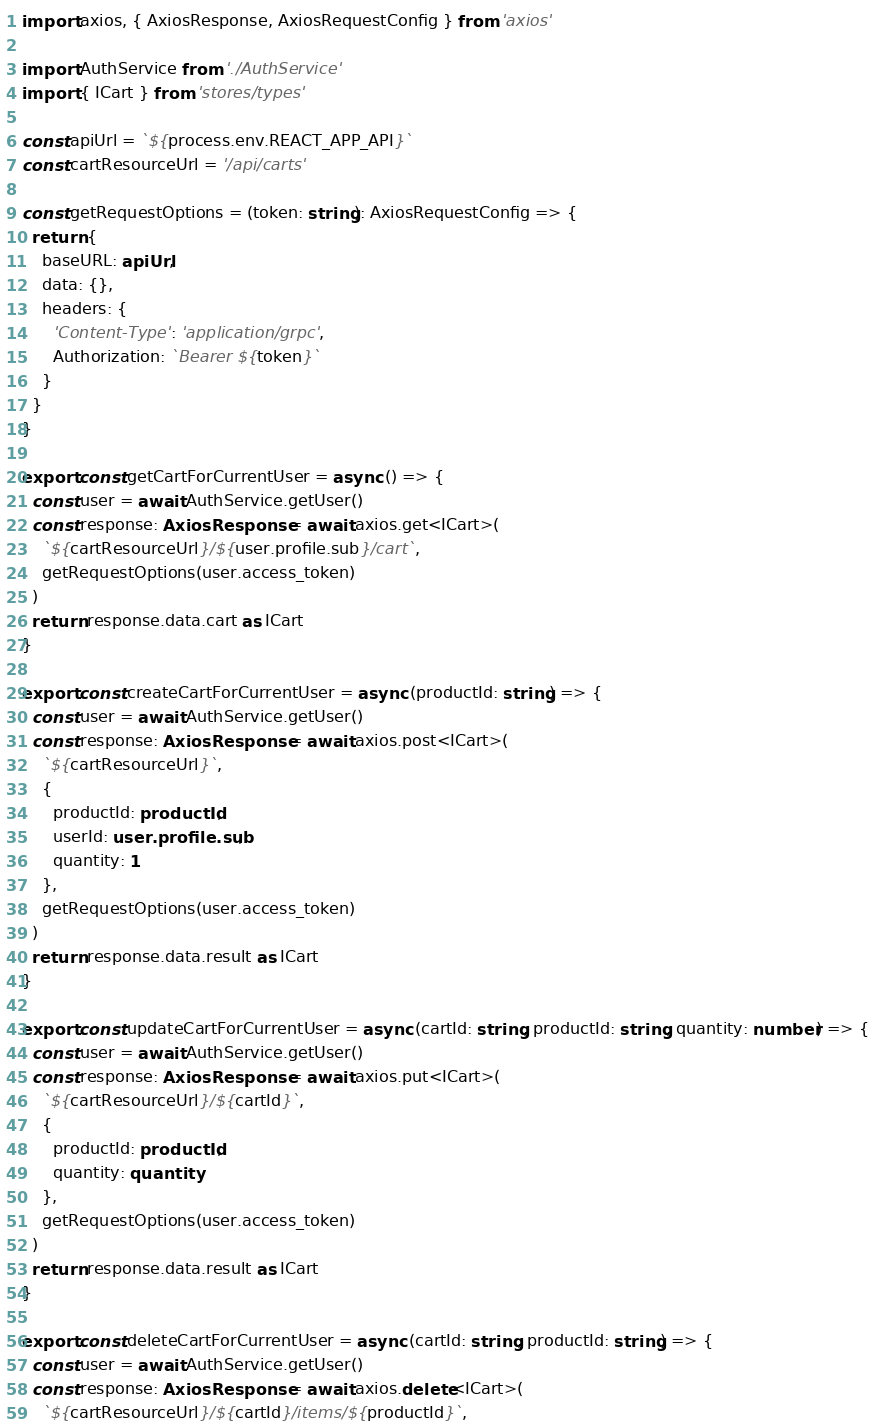<code> <loc_0><loc_0><loc_500><loc_500><_TypeScript_>import axios, { AxiosResponse, AxiosRequestConfig } from 'axios'

import AuthService from './AuthService'
import { ICart } from 'stores/types'

const apiUrl = `${process.env.REACT_APP_API}`
const cartResourceUrl = '/api/carts'

const getRequestOptions = (token: string): AxiosRequestConfig => {
  return {
    baseURL: apiUrl,
    data: {},
    headers: {
      'Content-Type': 'application/grpc',
      Authorization: `Bearer ${token}`
    }
  }
}

export const getCartForCurrentUser = async () => {
  const user = await AuthService.getUser()
  const response: AxiosResponse = await axios.get<ICart>(
    `${cartResourceUrl}/${user.profile.sub}/cart`,
    getRequestOptions(user.access_token)
  )
  return response.data.cart as ICart
}

export const createCartForCurrentUser = async (productId: string) => {
  const user = await AuthService.getUser()
  const response: AxiosResponse = await axios.post<ICart>(
    `${cartResourceUrl}`,
    {
      productId: productId,
      userId: user.profile.sub,
      quantity: 1
    },
    getRequestOptions(user.access_token)
  )
  return response.data.result as ICart
}

export const updateCartForCurrentUser = async (cartId: string, productId: string, quantity: number) => {
  const user = await AuthService.getUser()
  const response: AxiosResponse = await axios.put<ICart>(
    `${cartResourceUrl}/${cartId}`,
    {
      productId: productId,
      quantity: quantity
    },
    getRequestOptions(user.access_token)
  )
  return response.data.result as ICart
}

export const deleteCartForCurrentUser = async (cartId: string, productId: string) => {
  const user = await AuthService.getUser()
  const response: AxiosResponse = await axios.delete<ICart>(
    `${cartResourceUrl}/${cartId}/items/${productId}`,</code> 